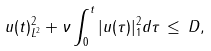Convert formula to latex. <formula><loc_0><loc_0><loc_500><loc_500>\| u ( t ) \| ^ { 2 } _ { L ^ { 2 } } + \nu \int _ { 0 } ^ { t } | u ( \tau ) | ^ { 2 } _ { 1 } d \tau \, \leq \, D ,</formula> 